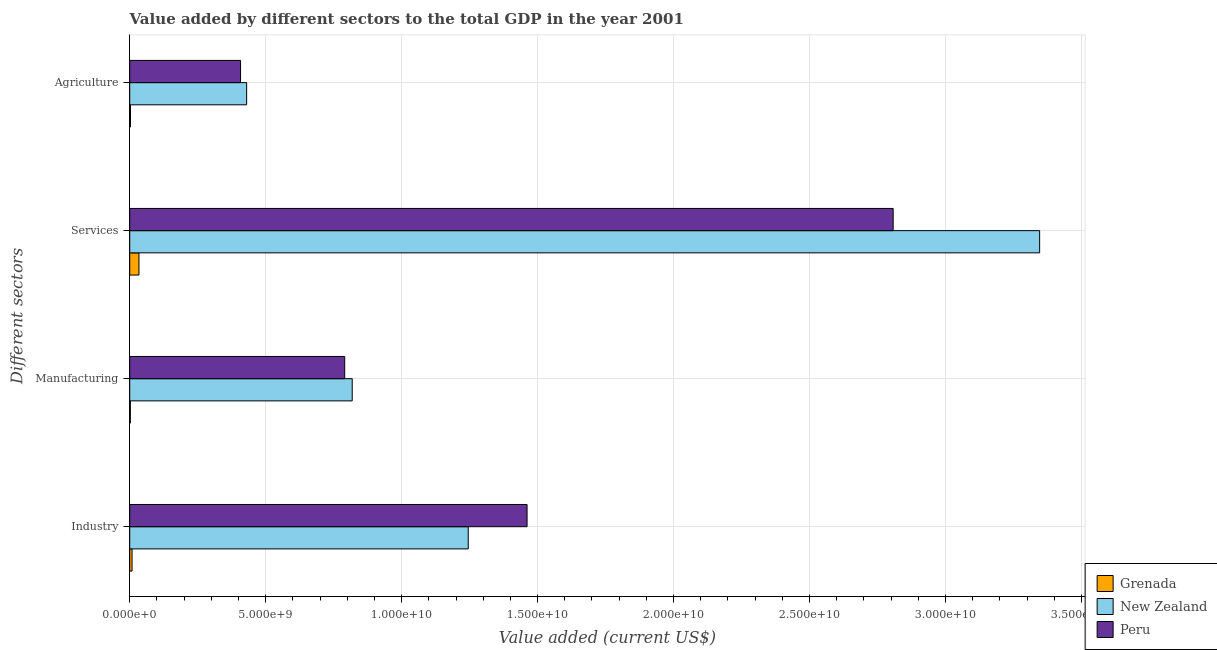How many different coloured bars are there?
Your answer should be compact. 3. How many groups of bars are there?
Provide a short and direct response. 4. Are the number of bars on each tick of the Y-axis equal?
Make the answer very short. Yes. What is the label of the 2nd group of bars from the top?
Your answer should be compact. Services. What is the value added by agricultural sector in Grenada?
Offer a very short reply. 2.79e+07. Across all countries, what is the maximum value added by agricultural sector?
Provide a succinct answer. 4.30e+09. Across all countries, what is the minimum value added by agricultural sector?
Provide a succinct answer. 2.79e+07. In which country was the value added by manufacturing sector maximum?
Make the answer very short. New Zealand. In which country was the value added by agricultural sector minimum?
Give a very brief answer. Grenada. What is the total value added by agricultural sector in the graph?
Your answer should be compact. 8.40e+09. What is the difference between the value added by manufacturing sector in Grenada and that in New Zealand?
Make the answer very short. -8.16e+09. What is the difference between the value added by services sector in Peru and the value added by agricultural sector in New Zealand?
Ensure brevity in your answer.  2.38e+1. What is the average value added by industrial sector per country?
Offer a terse response. 9.05e+09. What is the difference between the value added by industrial sector and value added by services sector in Peru?
Provide a succinct answer. -1.35e+1. What is the ratio of the value added by services sector in Peru to that in New Zealand?
Your answer should be very brief. 0.84. Is the value added by manufacturing sector in Grenada less than that in New Zealand?
Offer a terse response. Yes. Is the difference between the value added by agricultural sector in Peru and Grenada greater than the difference between the value added by industrial sector in Peru and Grenada?
Provide a short and direct response. No. What is the difference between the highest and the second highest value added by services sector?
Offer a terse response. 5.39e+09. What is the difference between the highest and the lowest value added by industrial sector?
Offer a very short reply. 1.45e+1. In how many countries, is the value added by agricultural sector greater than the average value added by agricultural sector taken over all countries?
Offer a very short reply. 2. Is it the case that in every country, the sum of the value added by industrial sector and value added by manufacturing sector is greater than the sum of value added by services sector and value added by agricultural sector?
Provide a succinct answer. No. What does the 3rd bar from the top in Services represents?
Offer a very short reply. Grenada. What does the 1st bar from the bottom in Industry represents?
Provide a succinct answer. Grenada. What is the difference between two consecutive major ticks on the X-axis?
Offer a terse response. 5.00e+09. Are the values on the major ticks of X-axis written in scientific E-notation?
Keep it short and to the point. Yes. Does the graph contain any zero values?
Ensure brevity in your answer.  No. How many legend labels are there?
Provide a short and direct response. 3. How are the legend labels stacked?
Your answer should be very brief. Vertical. What is the title of the graph?
Provide a short and direct response. Value added by different sectors to the total GDP in the year 2001. Does "Lithuania" appear as one of the legend labels in the graph?
Make the answer very short. No. What is the label or title of the X-axis?
Offer a very short reply. Value added (current US$). What is the label or title of the Y-axis?
Your answer should be very brief. Different sectors. What is the Value added (current US$) in Grenada in Industry?
Ensure brevity in your answer.  8.59e+07. What is the Value added (current US$) in New Zealand in Industry?
Your answer should be very brief. 1.24e+1. What is the Value added (current US$) of Peru in Industry?
Your answer should be very brief. 1.46e+1. What is the Value added (current US$) of Grenada in Manufacturing?
Your response must be concise. 2.35e+07. What is the Value added (current US$) of New Zealand in Manufacturing?
Your response must be concise. 8.18e+09. What is the Value added (current US$) of Peru in Manufacturing?
Ensure brevity in your answer.  7.91e+09. What is the Value added (current US$) in Grenada in Services?
Ensure brevity in your answer.  3.39e+08. What is the Value added (current US$) of New Zealand in Services?
Keep it short and to the point. 3.35e+1. What is the Value added (current US$) in Peru in Services?
Provide a succinct answer. 2.81e+1. What is the Value added (current US$) of Grenada in Agriculture?
Ensure brevity in your answer.  2.79e+07. What is the Value added (current US$) of New Zealand in Agriculture?
Your response must be concise. 4.30e+09. What is the Value added (current US$) in Peru in Agriculture?
Ensure brevity in your answer.  4.08e+09. Across all Different sectors, what is the maximum Value added (current US$) of Grenada?
Your answer should be very brief. 3.39e+08. Across all Different sectors, what is the maximum Value added (current US$) in New Zealand?
Offer a terse response. 3.35e+1. Across all Different sectors, what is the maximum Value added (current US$) of Peru?
Keep it short and to the point. 2.81e+1. Across all Different sectors, what is the minimum Value added (current US$) of Grenada?
Offer a terse response. 2.35e+07. Across all Different sectors, what is the minimum Value added (current US$) of New Zealand?
Offer a terse response. 4.30e+09. Across all Different sectors, what is the minimum Value added (current US$) of Peru?
Your answer should be compact. 4.08e+09. What is the total Value added (current US$) of Grenada in the graph?
Your answer should be compact. 4.77e+08. What is the total Value added (current US$) in New Zealand in the graph?
Offer a terse response. 5.84e+1. What is the total Value added (current US$) in Peru in the graph?
Offer a terse response. 5.47e+1. What is the difference between the Value added (current US$) of Grenada in Industry and that in Manufacturing?
Offer a terse response. 6.25e+07. What is the difference between the Value added (current US$) in New Zealand in Industry and that in Manufacturing?
Your response must be concise. 4.27e+09. What is the difference between the Value added (current US$) in Peru in Industry and that in Manufacturing?
Your response must be concise. 6.71e+09. What is the difference between the Value added (current US$) in Grenada in Industry and that in Services?
Ensure brevity in your answer.  -2.53e+08. What is the difference between the Value added (current US$) in New Zealand in Industry and that in Services?
Keep it short and to the point. -2.10e+1. What is the difference between the Value added (current US$) of Peru in Industry and that in Services?
Make the answer very short. -1.35e+1. What is the difference between the Value added (current US$) in Grenada in Industry and that in Agriculture?
Provide a succinct answer. 5.80e+07. What is the difference between the Value added (current US$) in New Zealand in Industry and that in Agriculture?
Keep it short and to the point. 8.15e+09. What is the difference between the Value added (current US$) in Peru in Industry and that in Agriculture?
Give a very brief answer. 1.05e+1. What is the difference between the Value added (current US$) in Grenada in Manufacturing and that in Services?
Offer a terse response. -3.16e+08. What is the difference between the Value added (current US$) in New Zealand in Manufacturing and that in Services?
Ensure brevity in your answer.  -2.53e+1. What is the difference between the Value added (current US$) of Peru in Manufacturing and that in Services?
Keep it short and to the point. -2.02e+1. What is the difference between the Value added (current US$) of Grenada in Manufacturing and that in Agriculture?
Your response must be concise. -4.47e+06. What is the difference between the Value added (current US$) in New Zealand in Manufacturing and that in Agriculture?
Your answer should be very brief. 3.88e+09. What is the difference between the Value added (current US$) in Peru in Manufacturing and that in Agriculture?
Your answer should be compact. 3.83e+09. What is the difference between the Value added (current US$) of Grenada in Services and that in Agriculture?
Offer a very short reply. 3.11e+08. What is the difference between the Value added (current US$) in New Zealand in Services and that in Agriculture?
Give a very brief answer. 2.92e+1. What is the difference between the Value added (current US$) in Peru in Services and that in Agriculture?
Your answer should be compact. 2.40e+1. What is the difference between the Value added (current US$) in Grenada in Industry and the Value added (current US$) in New Zealand in Manufacturing?
Your answer should be very brief. -8.10e+09. What is the difference between the Value added (current US$) in Grenada in Industry and the Value added (current US$) in Peru in Manufacturing?
Keep it short and to the point. -7.82e+09. What is the difference between the Value added (current US$) in New Zealand in Industry and the Value added (current US$) in Peru in Manufacturing?
Give a very brief answer. 4.54e+09. What is the difference between the Value added (current US$) in Grenada in Industry and the Value added (current US$) in New Zealand in Services?
Offer a terse response. -3.34e+1. What is the difference between the Value added (current US$) of Grenada in Industry and the Value added (current US$) of Peru in Services?
Offer a very short reply. -2.80e+1. What is the difference between the Value added (current US$) in New Zealand in Industry and the Value added (current US$) in Peru in Services?
Your response must be concise. -1.56e+1. What is the difference between the Value added (current US$) in Grenada in Industry and the Value added (current US$) in New Zealand in Agriculture?
Your response must be concise. -4.21e+09. What is the difference between the Value added (current US$) in Grenada in Industry and the Value added (current US$) in Peru in Agriculture?
Provide a short and direct response. -3.99e+09. What is the difference between the Value added (current US$) in New Zealand in Industry and the Value added (current US$) in Peru in Agriculture?
Make the answer very short. 8.37e+09. What is the difference between the Value added (current US$) in Grenada in Manufacturing and the Value added (current US$) in New Zealand in Services?
Offer a very short reply. -3.34e+1. What is the difference between the Value added (current US$) of Grenada in Manufacturing and the Value added (current US$) of Peru in Services?
Your answer should be very brief. -2.81e+1. What is the difference between the Value added (current US$) in New Zealand in Manufacturing and the Value added (current US$) in Peru in Services?
Your response must be concise. -1.99e+1. What is the difference between the Value added (current US$) in Grenada in Manufacturing and the Value added (current US$) in New Zealand in Agriculture?
Offer a terse response. -4.28e+09. What is the difference between the Value added (current US$) in Grenada in Manufacturing and the Value added (current US$) in Peru in Agriculture?
Give a very brief answer. -4.05e+09. What is the difference between the Value added (current US$) of New Zealand in Manufacturing and the Value added (current US$) of Peru in Agriculture?
Make the answer very short. 4.11e+09. What is the difference between the Value added (current US$) of Grenada in Services and the Value added (current US$) of New Zealand in Agriculture?
Make the answer very short. -3.96e+09. What is the difference between the Value added (current US$) of Grenada in Services and the Value added (current US$) of Peru in Agriculture?
Your answer should be very brief. -3.74e+09. What is the difference between the Value added (current US$) in New Zealand in Services and the Value added (current US$) in Peru in Agriculture?
Give a very brief answer. 2.94e+1. What is the average Value added (current US$) of Grenada per Different sectors?
Make the answer very short. 1.19e+08. What is the average Value added (current US$) in New Zealand per Different sectors?
Give a very brief answer. 1.46e+1. What is the average Value added (current US$) of Peru per Different sectors?
Your answer should be compact. 1.37e+1. What is the difference between the Value added (current US$) in Grenada and Value added (current US$) in New Zealand in Industry?
Keep it short and to the point. -1.24e+1. What is the difference between the Value added (current US$) in Grenada and Value added (current US$) in Peru in Industry?
Provide a succinct answer. -1.45e+1. What is the difference between the Value added (current US$) of New Zealand and Value added (current US$) of Peru in Industry?
Provide a succinct answer. -2.16e+09. What is the difference between the Value added (current US$) in Grenada and Value added (current US$) in New Zealand in Manufacturing?
Your answer should be compact. -8.16e+09. What is the difference between the Value added (current US$) of Grenada and Value added (current US$) of Peru in Manufacturing?
Your response must be concise. -7.88e+09. What is the difference between the Value added (current US$) of New Zealand and Value added (current US$) of Peru in Manufacturing?
Your answer should be very brief. 2.77e+08. What is the difference between the Value added (current US$) in Grenada and Value added (current US$) in New Zealand in Services?
Make the answer very short. -3.31e+1. What is the difference between the Value added (current US$) in Grenada and Value added (current US$) in Peru in Services?
Offer a terse response. -2.77e+1. What is the difference between the Value added (current US$) of New Zealand and Value added (current US$) of Peru in Services?
Provide a succinct answer. 5.39e+09. What is the difference between the Value added (current US$) of Grenada and Value added (current US$) of New Zealand in Agriculture?
Provide a succinct answer. -4.27e+09. What is the difference between the Value added (current US$) of Grenada and Value added (current US$) of Peru in Agriculture?
Offer a terse response. -4.05e+09. What is the difference between the Value added (current US$) of New Zealand and Value added (current US$) of Peru in Agriculture?
Your answer should be compact. 2.24e+08. What is the ratio of the Value added (current US$) in Grenada in Industry to that in Manufacturing?
Make the answer very short. 3.66. What is the ratio of the Value added (current US$) in New Zealand in Industry to that in Manufacturing?
Offer a very short reply. 1.52. What is the ratio of the Value added (current US$) of Peru in Industry to that in Manufacturing?
Your answer should be compact. 1.85. What is the ratio of the Value added (current US$) in Grenada in Industry to that in Services?
Offer a very short reply. 0.25. What is the ratio of the Value added (current US$) in New Zealand in Industry to that in Services?
Make the answer very short. 0.37. What is the ratio of the Value added (current US$) in Peru in Industry to that in Services?
Provide a short and direct response. 0.52. What is the ratio of the Value added (current US$) in Grenada in Industry to that in Agriculture?
Give a very brief answer. 3.08. What is the ratio of the Value added (current US$) in New Zealand in Industry to that in Agriculture?
Keep it short and to the point. 2.9. What is the ratio of the Value added (current US$) in Peru in Industry to that in Agriculture?
Give a very brief answer. 3.59. What is the ratio of the Value added (current US$) in Grenada in Manufacturing to that in Services?
Ensure brevity in your answer.  0.07. What is the ratio of the Value added (current US$) in New Zealand in Manufacturing to that in Services?
Give a very brief answer. 0.24. What is the ratio of the Value added (current US$) in Peru in Manufacturing to that in Services?
Your answer should be compact. 0.28. What is the ratio of the Value added (current US$) of Grenada in Manufacturing to that in Agriculture?
Your answer should be very brief. 0.84. What is the ratio of the Value added (current US$) of New Zealand in Manufacturing to that in Agriculture?
Your answer should be very brief. 1.9. What is the ratio of the Value added (current US$) of Peru in Manufacturing to that in Agriculture?
Give a very brief answer. 1.94. What is the ratio of the Value added (current US$) of Grenada in Services to that in Agriculture?
Keep it short and to the point. 12.15. What is the ratio of the Value added (current US$) in New Zealand in Services to that in Agriculture?
Give a very brief answer. 7.78. What is the ratio of the Value added (current US$) in Peru in Services to that in Agriculture?
Provide a short and direct response. 6.89. What is the difference between the highest and the second highest Value added (current US$) of Grenada?
Provide a succinct answer. 2.53e+08. What is the difference between the highest and the second highest Value added (current US$) of New Zealand?
Keep it short and to the point. 2.10e+1. What is the difference between the highest and the second highest Value added (current US$) in Peru?
Offer a very short reply. 1.35e+1. What is the difference between the highest and the lowest Value added (current US$) in Grenada?
Offer a very short reply. 3.16e+08. What is the difference between the highest and the lowest Value added (current US$) in New Zealand?
Offer a very short reply. 2.92e+1. What is the difference between the highest and the lowest Value added (current US$) of Peru?
Offer a very short reply. 2.40e+1. 